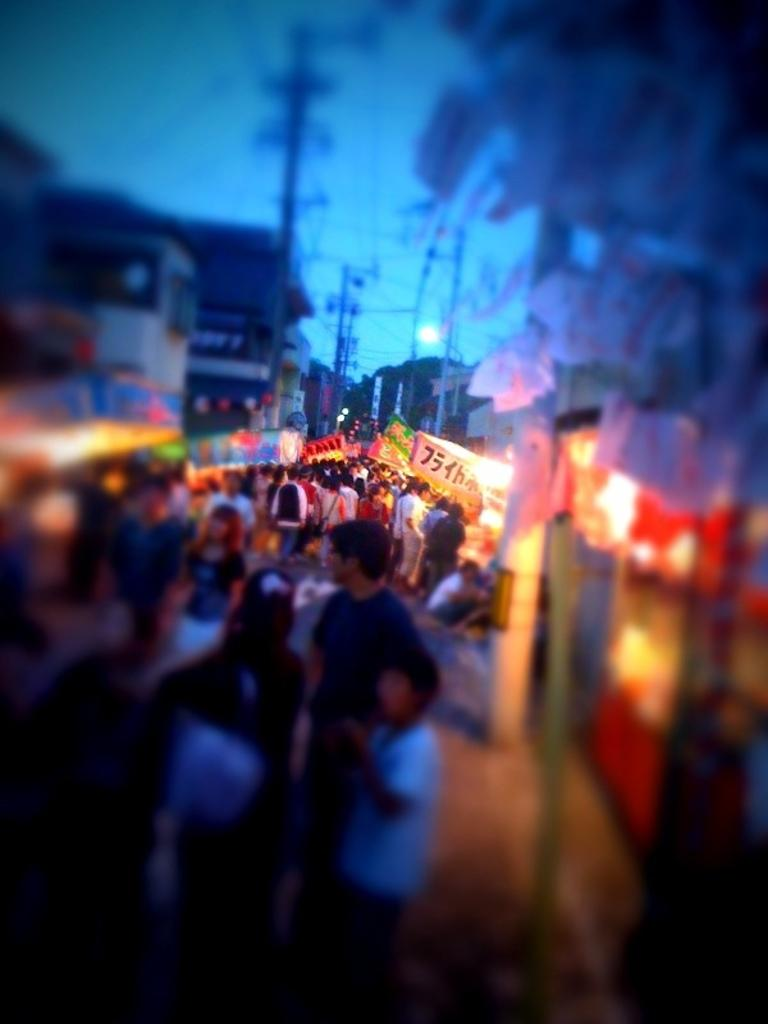What is happening on the road in the image? There are people on the road in the image. What can be seen in the background of the image? In the background of the image, there are banners, lights, poles, wires, and buildings. What might be used for communication or display purposes in the image? The banners in the background of the image might be used for communication or display purposes. What objects are visible in the image that might be related to paperwork or documentation? There are papers visible in the image. What type of knee injury can be seen in the image? There is no knee injury present in the image; it features people on the road and various background elements. What type of leather material is visible in the image? There is no leather material present in the image. 